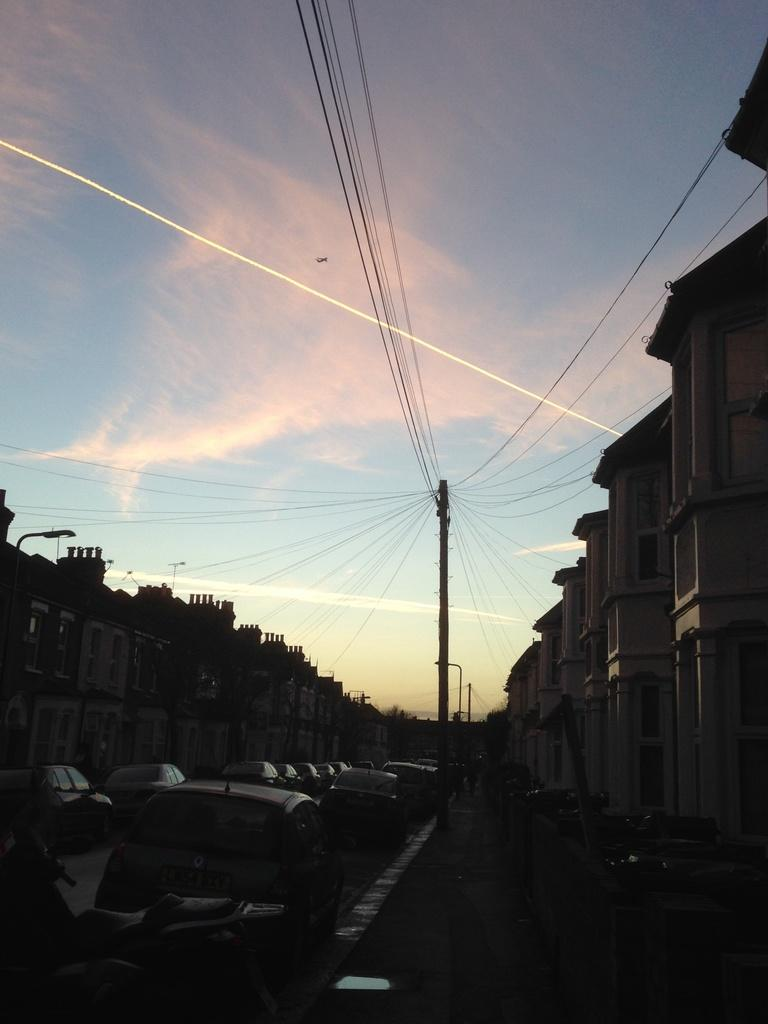What type of structure is visible in the image? There is a building in the image. What else can be seen on the ground in the image? There are vehicles on the road in the image. What is present above the ground in the image? There are poles with wires in the image. What can be seen in the distance in the image? The sky is visible in the background of the image. What type of pets are listed on the mass of the building in the image? There are no pets or lists present on the building in the image. 